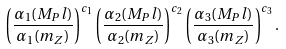<formula> <loc_0><loc_0><loc_500><loc_500>\left ( \frac { \alpha _ { 1 } ( M _ { P } l ) } { \alpha _ { 1 } ( m _ { Z } ) } \right ) ^ { c _ { 1 } } \left ( \frac { \alpha _ { 2 } ( M _ { P } l ) } { \alpha _ { 2 } ( m _ { Z } ) } \right ) ^ { c _ { 2 } } \left ( \frac { \alpha _ { 3 } ( M _ { P } l ) } { \alpha _ { 3 } ( m _ { Z } ) } \right ) ^ { c _ { 3 } } .</formula> 